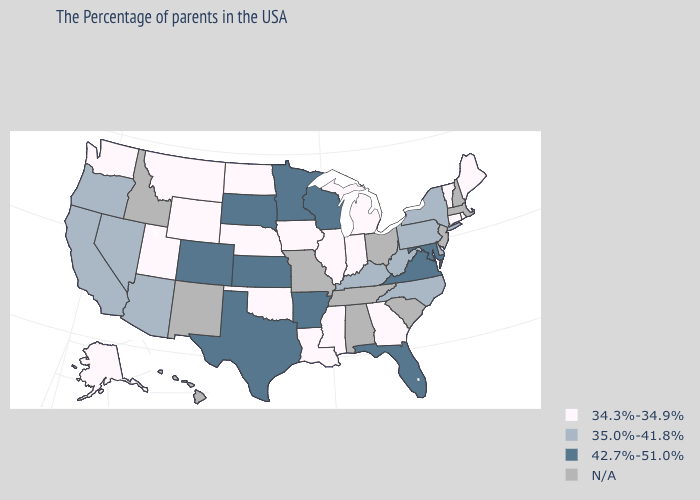What is the lowest value in the West?
Answer briefly. 34.3%-34.9%. Name the states that have a value in the range 34.3%-34.9%?
Keep it brief. Maine, Rhode Island, Vermont, Connecticut, Georgia, Michigan, Indiana, Illinois, Mississippi, Louisiana, Iowa, Nebraska, Oklahoma, North Dakota, Wyoming, Utah, Montana, Washington, Alaska. Does the map have missing data?
Be succinct. Yes. Does Vermont have the lowest value in the USA?
Give a very brief answer. Yes. What is the highest value in states that border Iowa?
Give a very brief answer. 42.7%-51.0%. What is the value of Rhode Island?
Be succinct. 34.3%-34.9%. What is the value of New Jersey?
Give a very brief answer. N/A. What is the value of Virginia?
Be succinct. 42.7%-51.0%. Which states hav the highest value in the Northeast?
Concise answer only. New York, Pennsylvania. Among the states that border New York , which have the highest value?
Give a very brief answer. Pennsylvania. What is the value of Massachusetts?
Concise answer only. N/A. What is the highest value in states that border Montana?
Write a very short answer. 42.7%-51.0%. Among the states that border New York , which have the lowest value?
Quick response, please. Vermont, Connecticut. What is the highest value in states that border Kentucky?
Concise answer only. 42.7%-51.0%. 